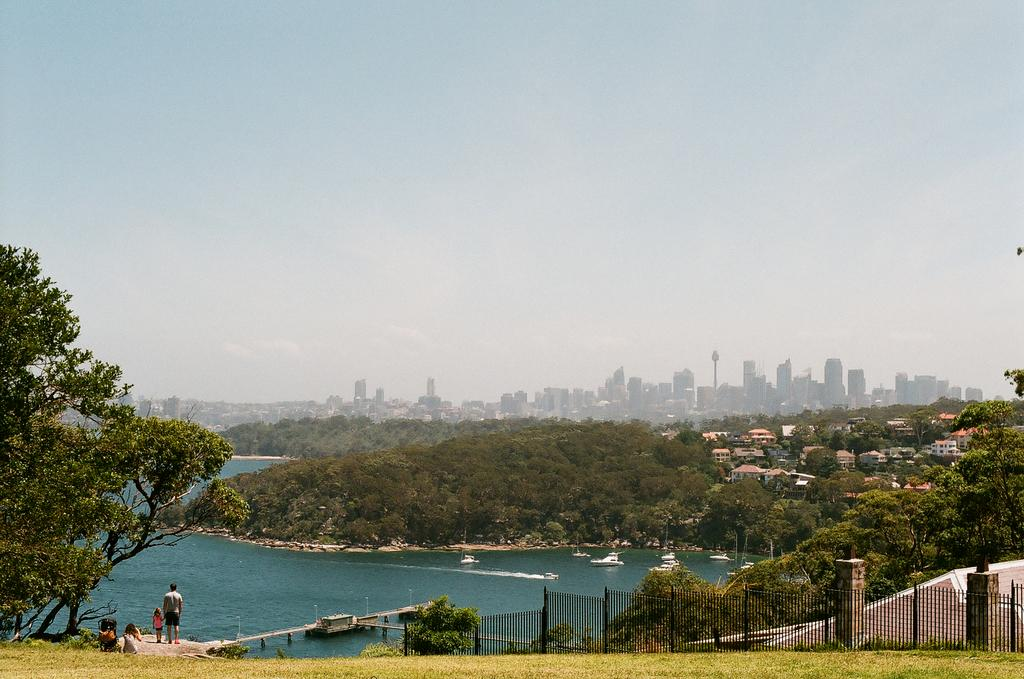What type of structures can be seen in the image? There are buildings, towers, and a walkway bridge in the image. What type of natural elements are present in the image? There are trees, hills, and water in the image. What type of vehicles can be seen in the image? There are ships on the water in the image. What type of recreational activity might be taking place in the image? There are grills in the image, which suggests that people might be barbecuing or cooking. What type of terrain is visible in the image? There are hills and a rock in the image. What is visible in the background of the image? The sky, clouds, and possibly more buildings can be seen in the background of the image. What type of protest is taking place in the image? There is no protest present in the image. What type of downtown area can be seen in the image? There is no downtown area mentioned in the image; it features a mix of natural and man-made elements. What type of music can be heard playing in the image? There is no mention of music or any sound in the image. 